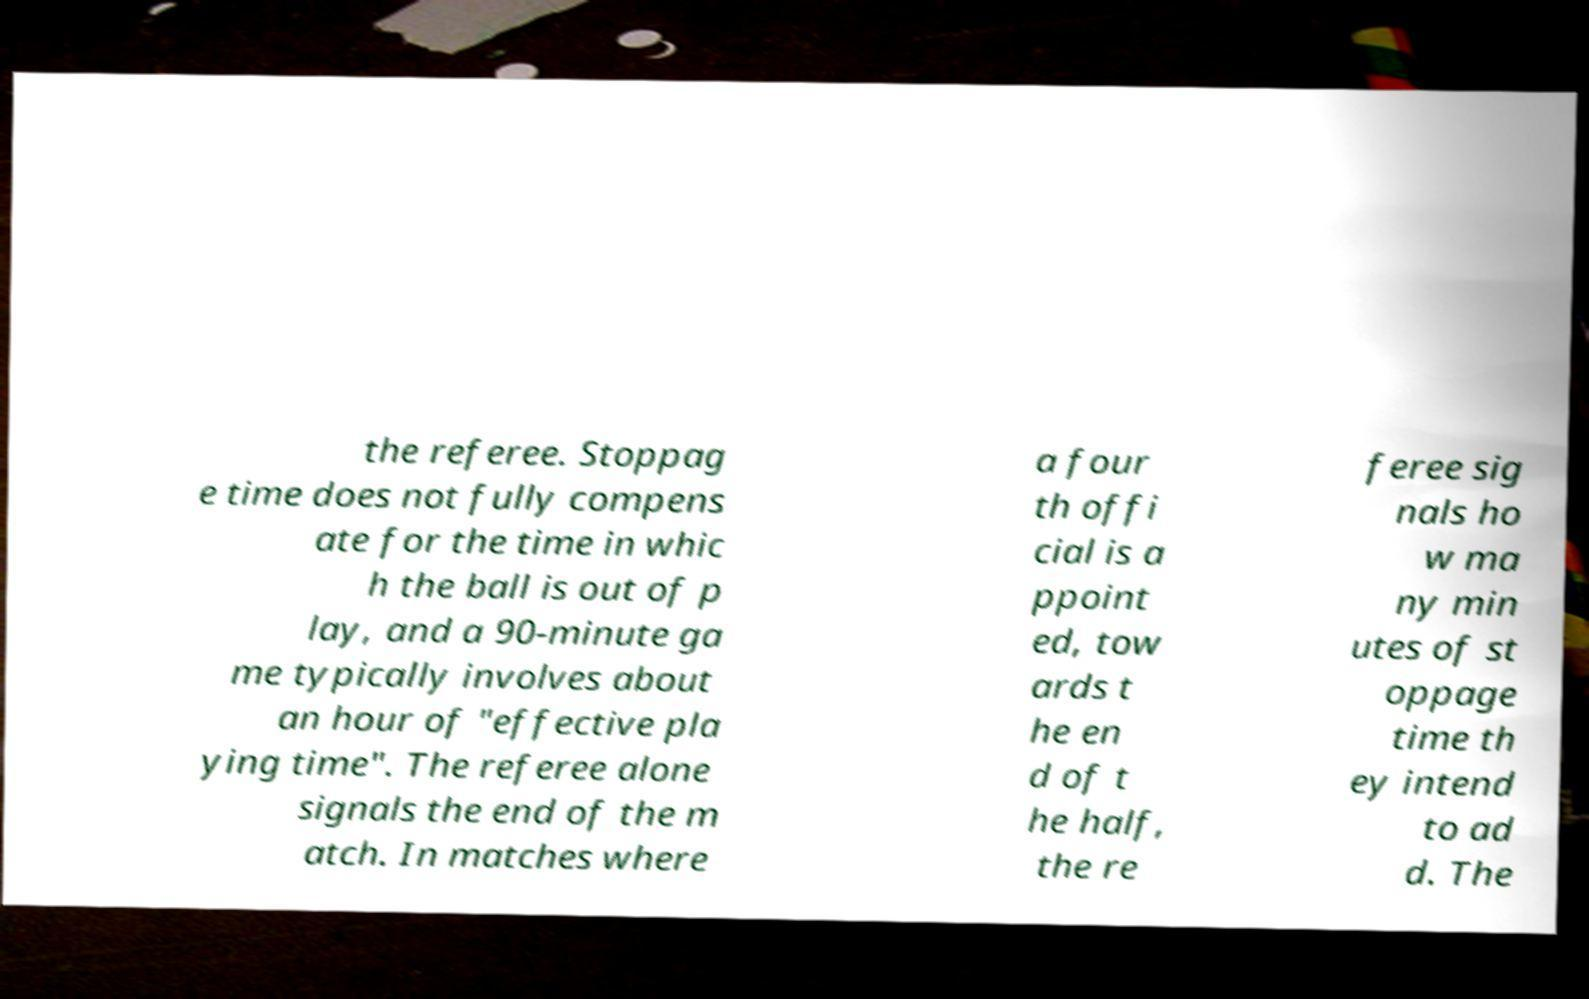Could you extract and type out the text from this image? the referee. Stoppag e time does not fully compens ate for the time in whic h the ball is out of p lay, and a 90-minute ga me typically involves about an hour of "effective pla ying time". The referee alone signals the end of the m atch. In matches where a four th offi cial is a ppoint ed, tow ards t he en d of t he half, the re feree sig nals ho w ma ny min utes of st oppage time th ey intend to ad d. The 